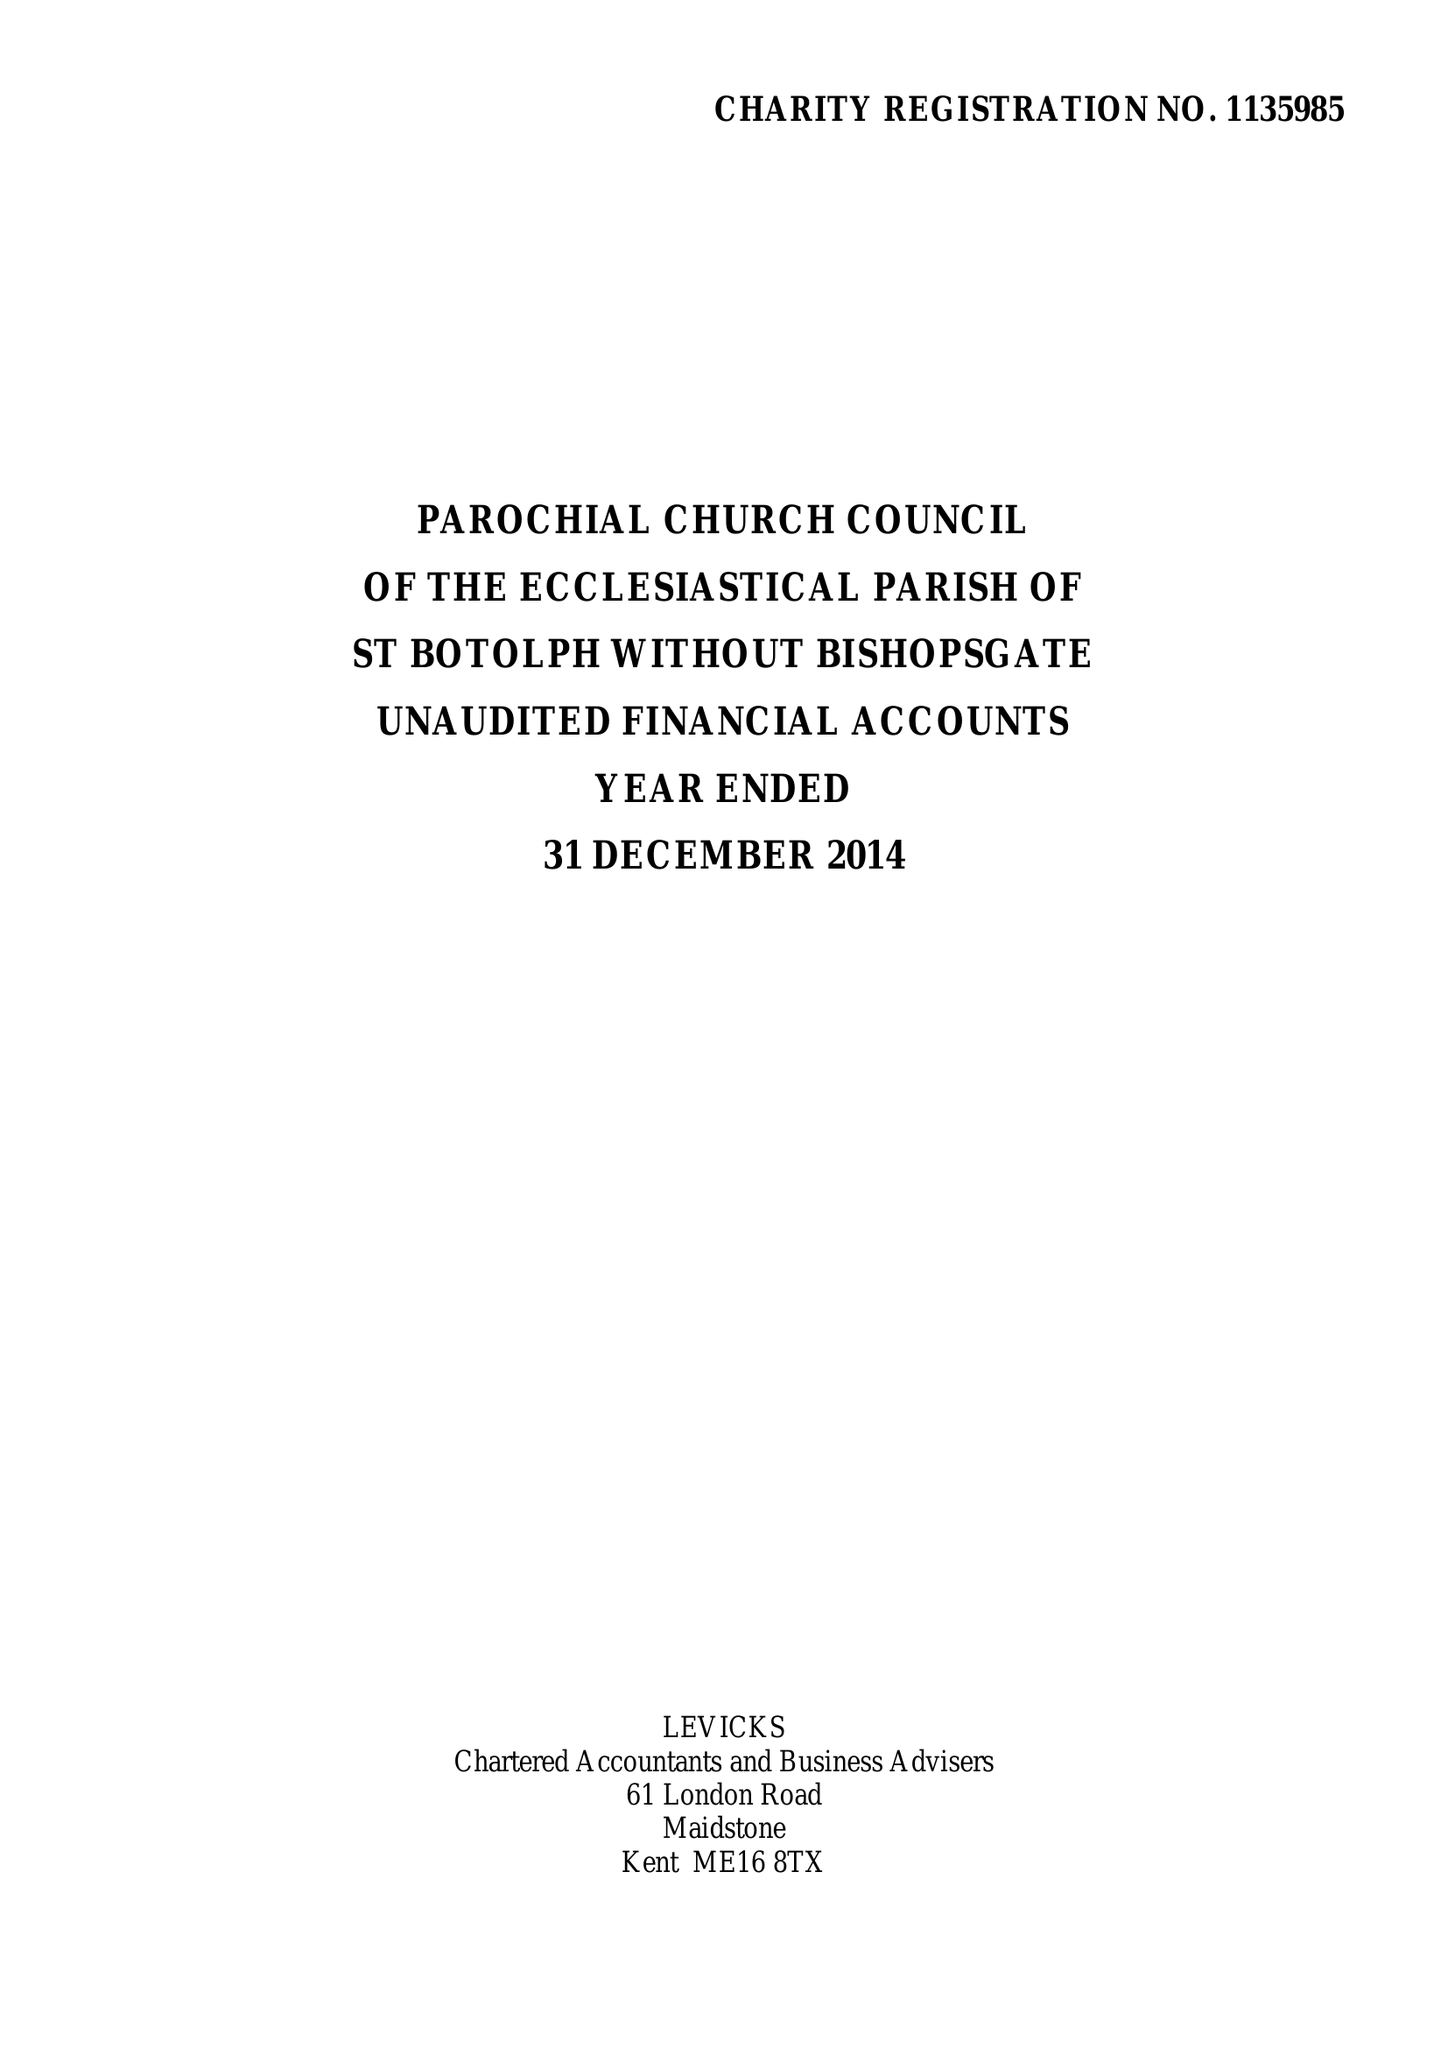What is the value for the income_annually_in_british_pounds?
Answer the question using a single word or phrase. 280057.00 